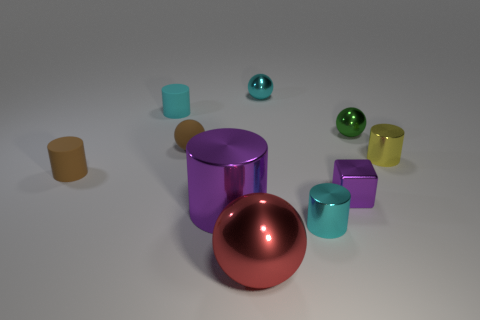There is a small cylinder that is in front of the yellow thing and right of the brown cylinder; what color is it?
Offer a terse response. Cyan. Is the number of small blue cylinders greater than the number of blocks?
Make the answer very short. No. What number of objects are either tiny yellow rubber cylinders or small cyan cylinders on the right side of the cyan metallic sphere?
Provide a short and direct response. 1. Is the purple cylinder the same size as the yellow shiny thing?
Give a very brief answer. No. There is a tiny yellow object; are there any tiny rubber things in front of it?
Your response must be concise. Yes. How big is the cyan thing that is in front of the small cyan sphere and to the right of the large purple cylinder?
Your response must be concise. Small. What number of objects are big things or small brown objects?
Provide a short and direct response. 4. Is the size of the cyan rubber cylinder the same as the cylinder on the right side of the small green object?
Make the answer very short. Yes. What is the size of the purple metal block that is to the right of the metallic cylinder on the left side of the small cyan object to the right of the cyan metal ball?
Offer a terse response. Small. Are any red metal things visible?
Ensure brevity in your answer.  Yes. 